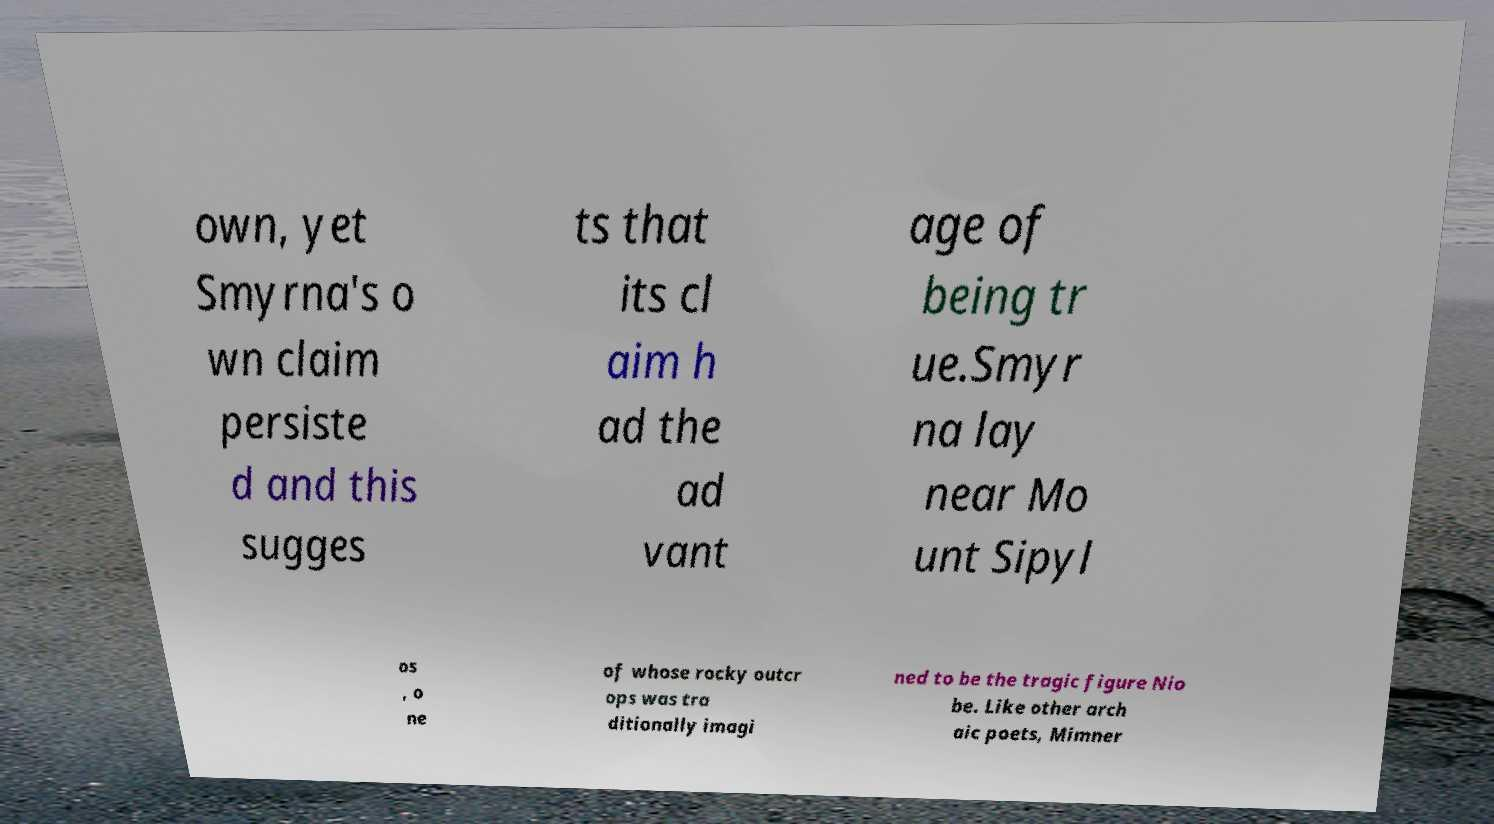What messages or text are displayed in this image? I need them in a readable, typed format. own, yet Smyrna's o wn claim persiste d and this sugges ts that its cl aim h ad the ad vant age of being tr ue.Smyr na lay near Mo unt Sipyl os , o ne of whose rocky outcr ops was tra ditionally imagi ned to be the tragic figure Nio be. Like other arch aic poets, Mimner 